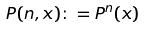<formula> <loc_0><loc_0><loc_500><loc_500>P ( n , x ) \colon = P ^ { n } ( x )</formula> 